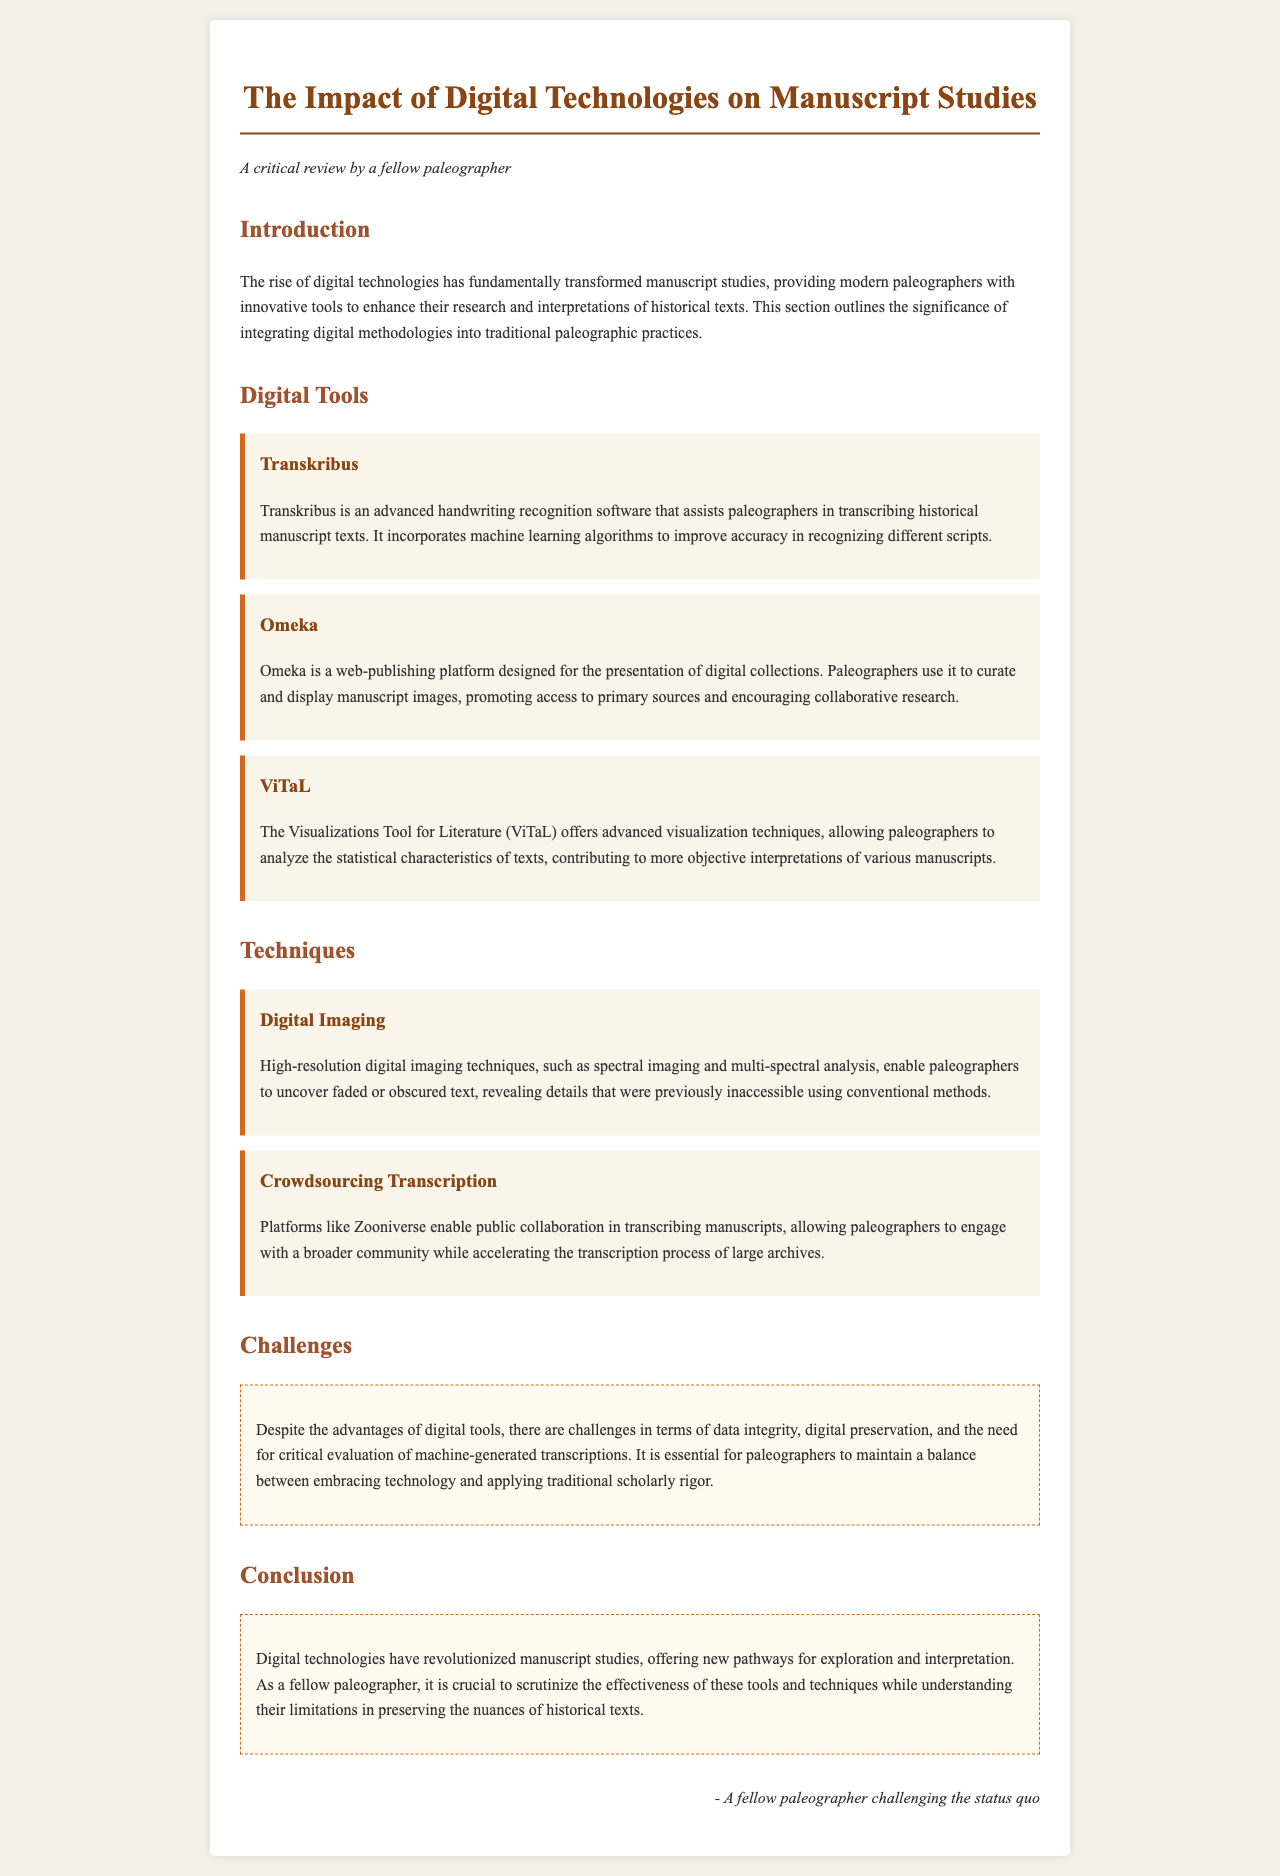What is the title of the report? The title of the report is explicitly stated at the beginning of the document.
Answer: The Impact of Digital Technologies on Manuscript Studies What software assists paleographers in transcribing historical manuscript texts? The document lists various tools used by paleographers, one of which is specifically focused on transcription.
Answer: Transkribus What platform does the document mention for curating and displaying manuscript images? The document describes various tools, and one is noted for its web-publishing capabilities.
Answer: Omeka Which imaging technique reveals details previously inaccessible using conventional methods? This is highlighted in the techniques section, showcasing advancements in imaging.
Answer: High-resolution digital imaging What challenge is associated with machine-generated transcriptions? The document addresses challenges faced by paleographers when utilizing digital tools.
Answer: Critical evaluation What does ViTaL stand for? The document abbreviates the name of a tool prominently featured in the tools section.
Answer: Visualizations Tool for Literature What community platform is mentioned for crowdsourcing transcription? The document points to a specific platform aimed at involving the public in transcription efforts.
Answer: Zooniverse What color signifies the challenges section in the document? The document employs a visual color cue to differentiate sections, including challenges.
Answer: White What essential balance must paleographers maintain according to the conclusion? The conclusion reflects on the relationship between new technology and traditional methods.
Answer: Technology and scholarly rigor 